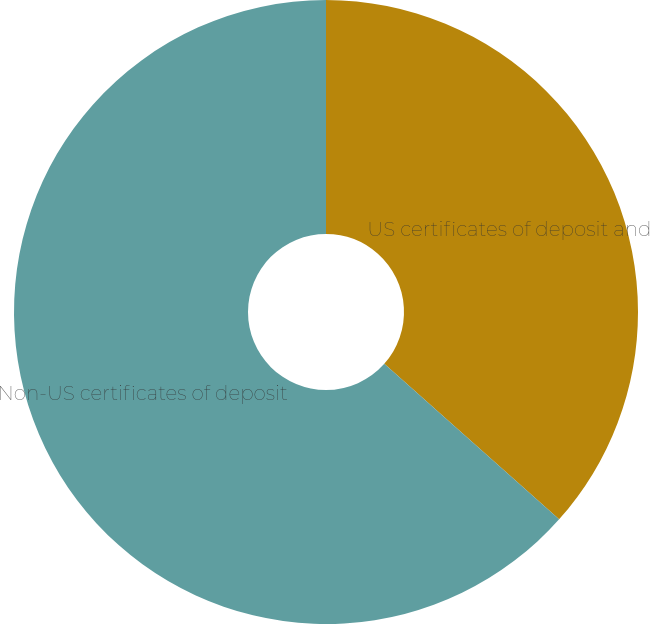Convert chart. <chart><loc_0><loc_0><loc_500><loc_500><pie_chart><fcel>US certificates of deposit and<fcel>Non-US certificates of deposit<nl><fcel>36.57%<fcel>63.43%<nl></chart> 